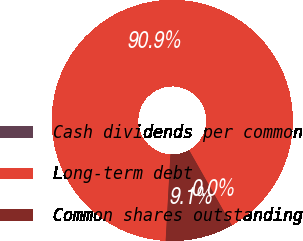<chart> <loc_0><loc_0><loc_500><loc_500><pie_chart><fcel>Cash dividends per common<fcel>Long-term debt<fcel>Common shares outstanding<nl><fcel>0.0%<fcel>90.9%<fcel>9.09%<nl></chart> 